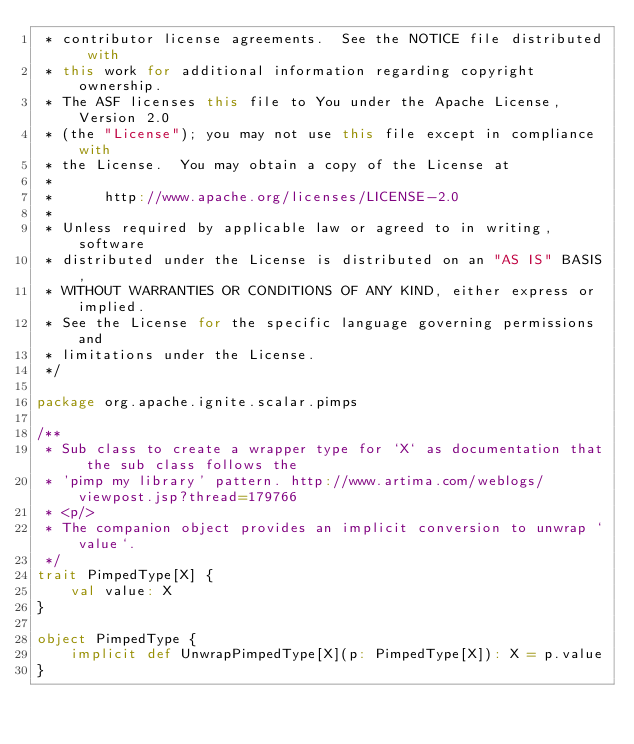<code> <loc_0><loc_0><loc_500><loc_500><_Scala_> * contributor license agreements.  See the NOTICE file distributed with
 * this work for additional information regarding copyright ownership.
 * The ASF licenses this file to You under the Apache License, Version 2.0
 * (the "License"); you may not use this file except in compliance with
 * the License.  You may obtain a copy of the License at
 *
 *      http://www.apache.org/licenses/LICENSE-2.0
 *
 * Unless required by applicable law or agreed to in writing, software
 * distributed under the License is distributed on an "AS IS" BASIS,
 * WITHOUT WARRANTIES OR CONDITIONS OF ANY KIND, either express or implied.
 * See the License for the specific language governing permissions and
 * limitations under the License.
 */

package org.apache.ignite.scalar.pimps

/**
 * Sub class to create a wrapper type for `X` as documentation that the sub class follows the
 * 'pimp my library' pattern. http://www.artima.com/weblogs/viewpost.jsp?thread=179766
 * <p/>
 * The companion object provides an implicit conversion to unwrap `value`.
 */
trait PimpedType[X] {
    val value: X
}

object PimpedType {
    implicit def UnwrapPimpedType[X](p: PimpedType[X]): X = p.value
}
</code> 